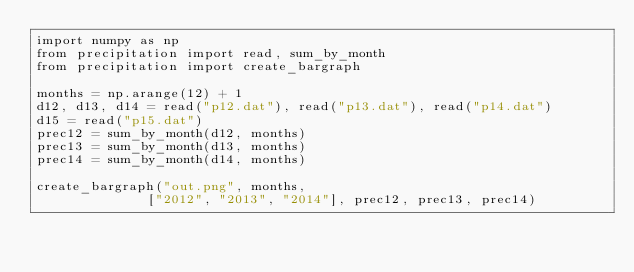Convert code to text. <code><loc_0><loc_0><loc_500><loc_500><_Python_>import numpy as np
from precipitation import read, sum_by_month
from precipitation import create_bargraph

months = np.arange(12) + 1
d12, d13, d14 = read("p12.dat"), read("p13.dat"), read("p14.dat")
d15 = read("p15.dat")
prec12 = sum_by_month(d12, months)
prec13 = sum_by_month(d13, months)
prec14 = sum_by_month(d14, months)

create_bargraph("out.png", months,
	            ["2012", "2013", "2014"], prec12, prec13, prec14)
</code> 